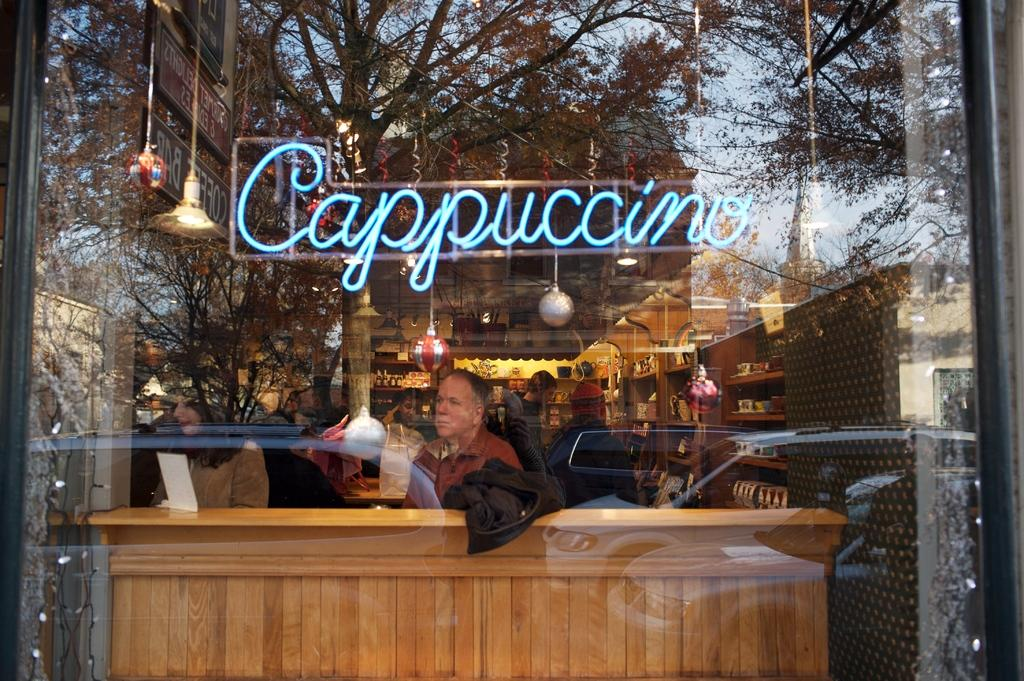What material is used for the object that is transparent in the image? There is transparent glass in the image. How many people can be seen in the image? There are many people visible in the image. What type of items are stored in the racks in the image? There are groceries in the racks in the image. What can be read or identified in the image? There is a word visible in the image. What type of decoration is present in the image? There is decoration in the image. What type of lighting is present in the image? There are lights in the image. How many legs does the mark have in the image? There is no mark present in the image, and therefore no legs can be counted. What type of shade is covering the decoration in the image? There is no shade covering the decoration in the image; it is visible without any obstruction. 